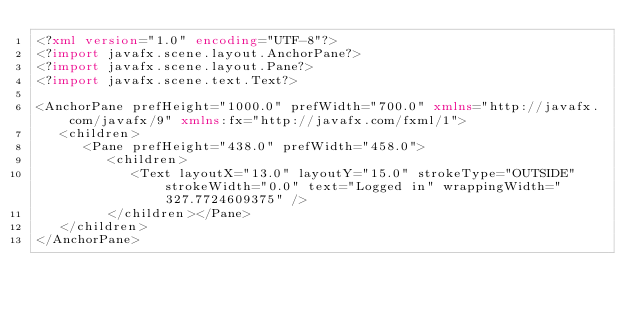Convert code to text. <code><loc_0><loc_0><loc_500><loc_500><_XML_><?xml version="1.0" encoding="UTF-8"?>
<?import javafx.scene.layout.AnchorPane?>
<?import javafx.scene.layout.Pane?>
<?import javafx.scene.text.Text?>

<AnchorPane prefHeight="1000.0" prefWidth="700.0" xmlns="http://javafx.com/javafx/9" xmlns:fx="http://javafx.com/fxml/1">
   <children>
      <Pane prefHeight="438.0" prefWidth="458.0">
         <children>
            <Text layoutX="13.0" layoutY="15.0" strokeType="OUTSIDE" strokeWidth="0.0" text="Logged in" wrappingWidth="327.7724609375" />
         </children></Pane>
   </children>
</AnchorPane>
</code> 